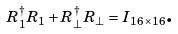<formula> <loc_0><loc_0><loc_500><loc_500>R _ { 1 } ^ { \dagger } R _ { 1 } + R _ { \perp } ^ { \dagger } R _ { \perp } = I _ { 1 6 \times 1 6 } \text {.}</formula> 